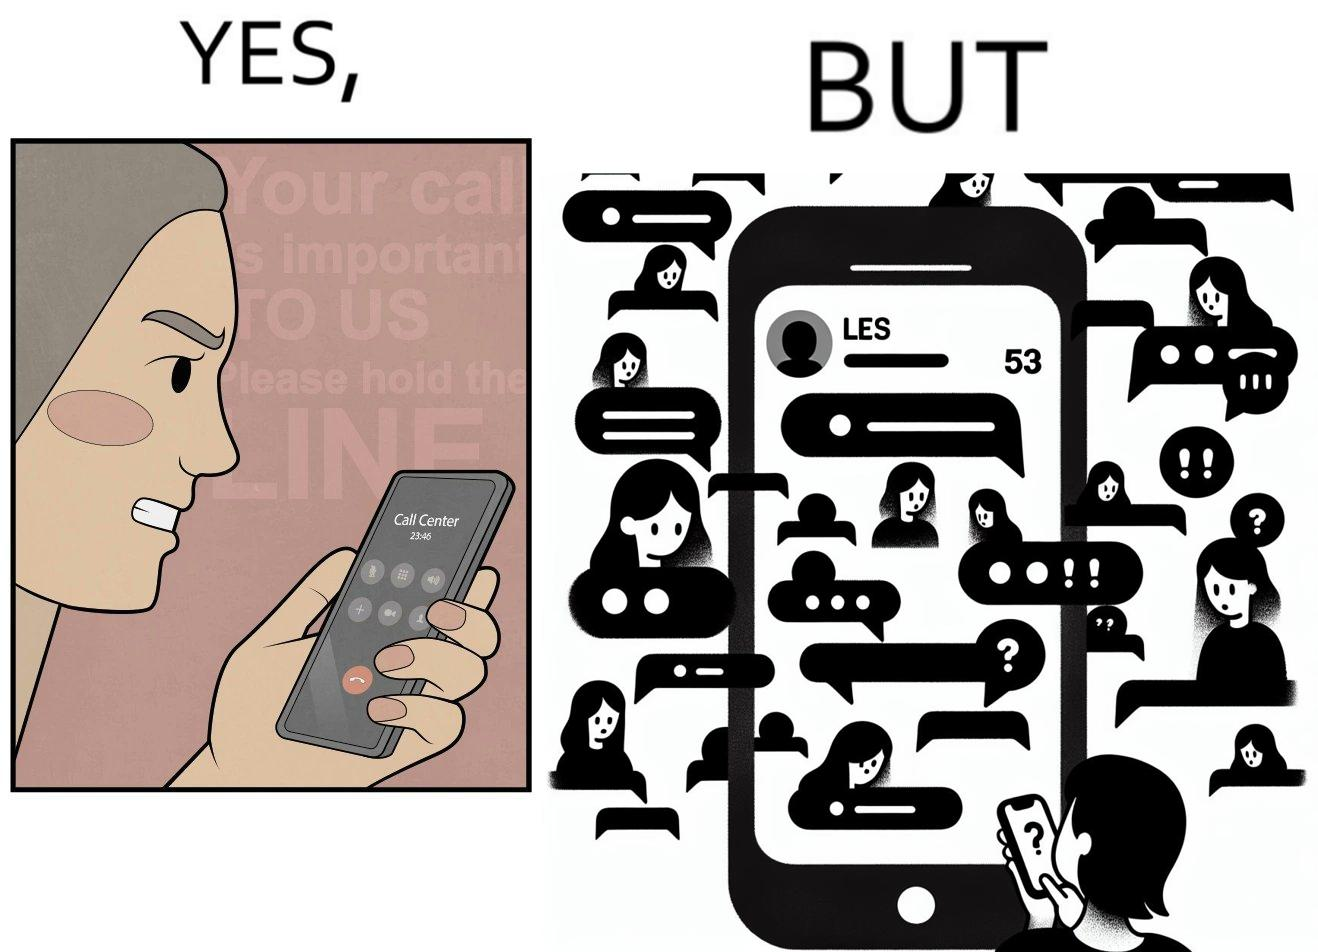Would you classify this image as satirical? Yes, this image is satirical. 